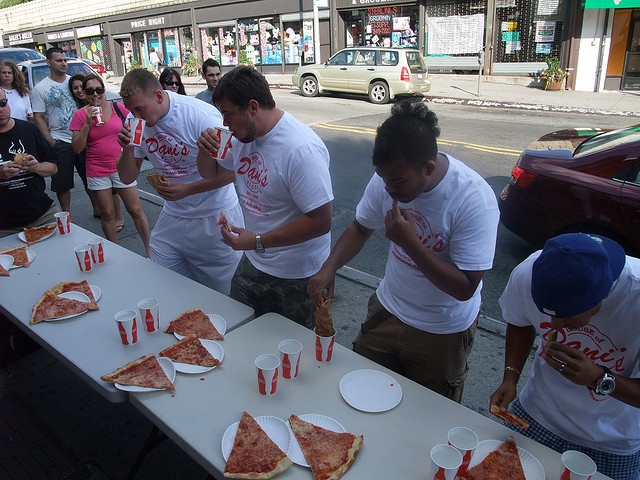Describe the objects in this image and their specific colors. I can see dining table in lightgray, gray, and darkgray tones, people in lightgray, black, gray, and darkgray tones, people in lightgray, black, gray, navy, and darkblue tones, dining table in lightgray, darkgray, gray, and maroon tones, and people in lightgray, black, gray, and maroon tones in this image. 